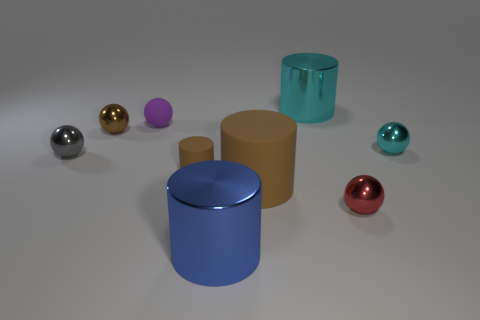How many brown cylinders must be subtracted to get 1 brown cylinders? 1 Subtract all big cylinders. How many cylinders are left? 1 Subtract 1 cylinders. How many cylinders are left? 3 Add 1 red spheres. How many objects exist? 10 Subtract all cylinders. How many objects are left? 5 Subtract 0 cyan cubes. How many objects are left? 9 Subtract all brown spheres. Subtract all purple cylinders. How many spheres are left? 4 Subtract all gray cylinders. How many blue spheres are left? 0 Subtract all small brown objects. Subtract all big cylinders. How many objects are left? 4 Add 3 metal objects. How many metal objects are left? 9 